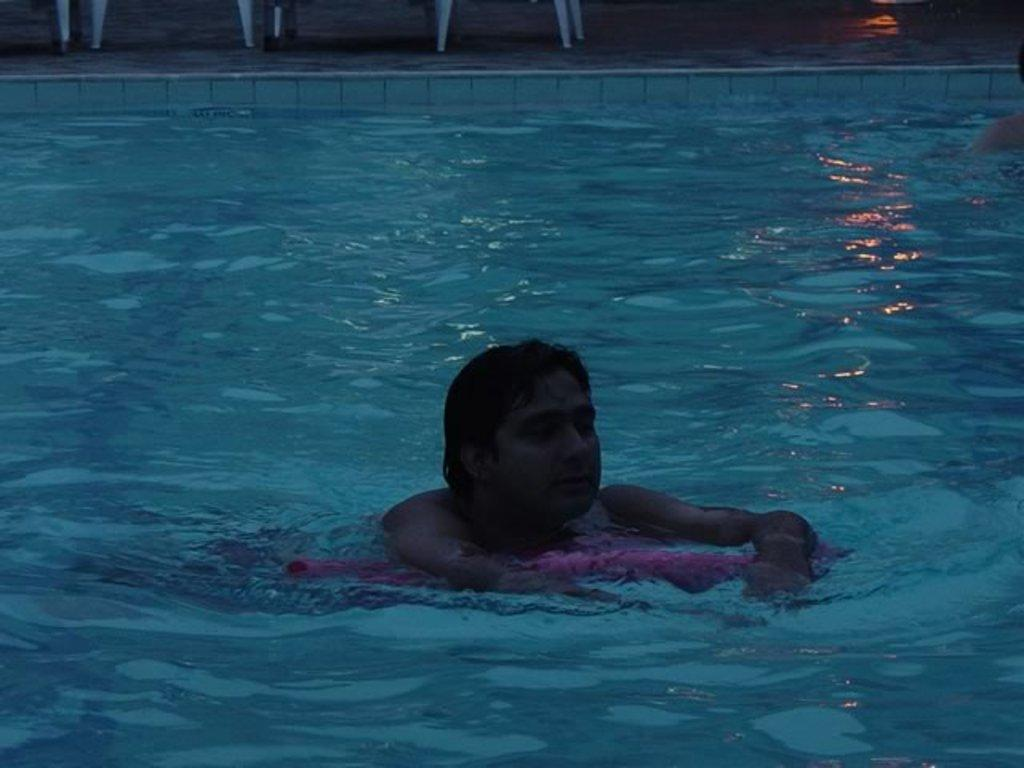What is the main subject of the image? There is a person in the image. What is the person doing in the image? The person is swimming in the image. Where is the person swimming? The swimming is taking place in a swimming pool. What type of letters can be seen floating in the swimming pool in the image? There are no letters visible in the swimming pool in the image. What color is the person's hair while they are swimming in the image? The provided facts do not mention the color of the person's hair, so we cannot determine the hair color from the image. 